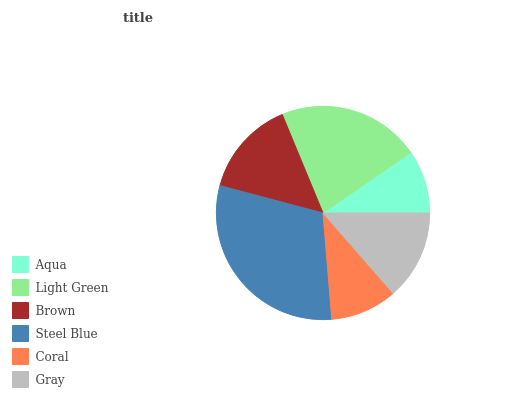Is Aqua the minimum?
Answer yes or no. Yes. Is Steel Blue the maximum?
Answer yes or no. Yes. Is Light Green the minimum?
Answer yes or no. No. Is Light Green the maximum?
Answer yes or no. No. Is Light Green greater than Aqua?
Answer yes or no. Yes. Is Aqua less than Light Green?
Answer yes or no. Yes. Is Aqua greater than Light Green?
Answer yes or no. No. Is Light Green less than Aqua?
Answer yes or no. No. Is Brown the high median?
Answer yes or no. Yes. Is Gray the low median?
Answer yes or no. Yes. Is Gray the high median?
Answer yes or no. No. Is Light Green the low median?
Answer yes or no. No. 